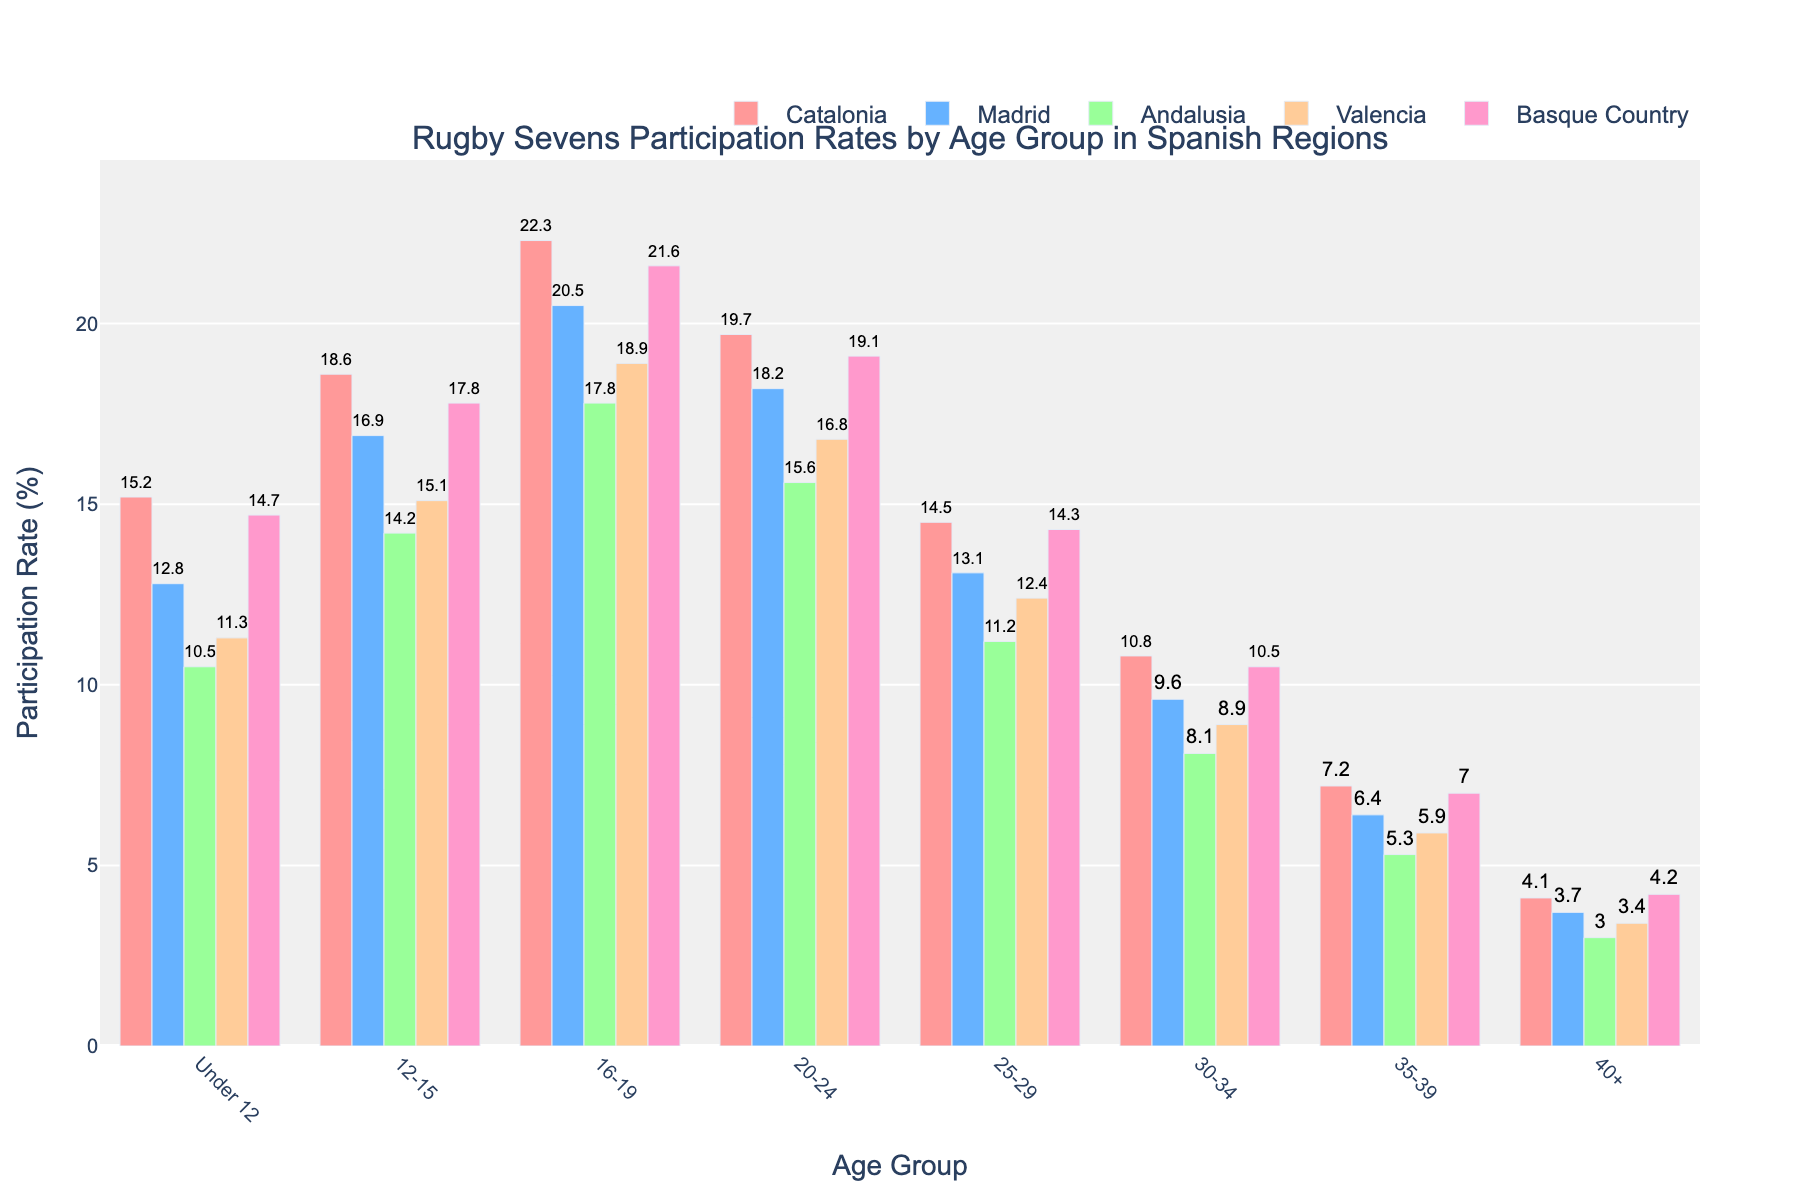Which age group has the highest participation rate in Catalonia? Looking at the bar heights for Catalonia, the 16-19 age group has the tallest bar, indicating the highest participation rate.
Answer: 16-19 Which region has the lowest participation rate for the 25-29 age group? By comparing the bar heights for the 25-29 age group across all regions, Andalusia has the shortest bar, hence the lowest participation rate.
Answer: Andalusia What is the average participation rate of the Under 12 age group across all regions? Sum the participation rates of the Under 12 age group and divide by the number of regions: (15.2 + 12.8 + 10.5 + 11.3 + 14.7) / 5 = 12.9
Answer: 12.9 Which age group in Valencia has a higher participation rate: 12-15 or 20-24? Compare the heights of the bars for the 12-15 and 20-24 age groups in Valencia. The bar for the 12-15 age group is higher.
Answer: 12-15 How much higher is the participation rate for the 16-19 age group compared to the 12-15 age group in Madrid? Subtract the participation rate of the 12-15 age group from the 16-19 age group in Madrid: 20.5 - 16.9 = 3.6
Answer: 3.6 Is there any age group where Madrid has the highest participation rate compared to other regions? For each age group, check if the bar for Madrid is the tallest. Madrid does not have the tallest bar in any age group.
Answer: No What is the participation rate difference between the 20-24 and 35-39 age groups in the Basque Country? Subtract the participation rate of the 35-39 age group from the 20-24 age group in the Basque Country: 19.1 - 7.0 = 12.1
Answer: 12.1 How many regions have a participation rate greater than 10% for the 30-34 age group? Count the number of bars taller than the 10% mark for the 30-34 age group. Three regions (Catalonia, Madrid, Basque Country) have participation rates above 10%.
Answer: 3 